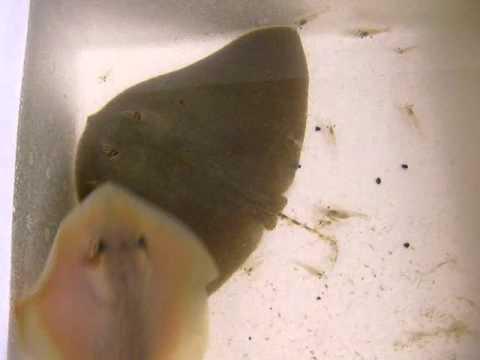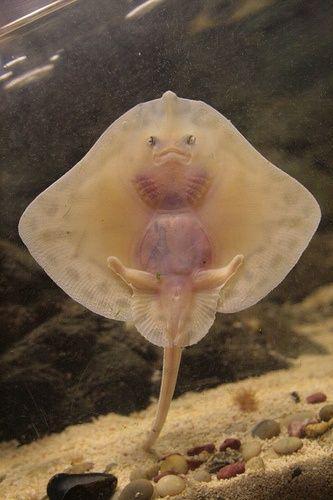The first image is the image on the left, the second image is the image on the right. Examine the images to the left and right. Is the description "There are more rays in the image on the left than in the image on the right." accurate? Answer yes or no. Yes. The first image is the image on the left, the second image is the image on the right. For the images shown, is this caption "There are more than 2 rays." true? Answer yes or no. Yes. 